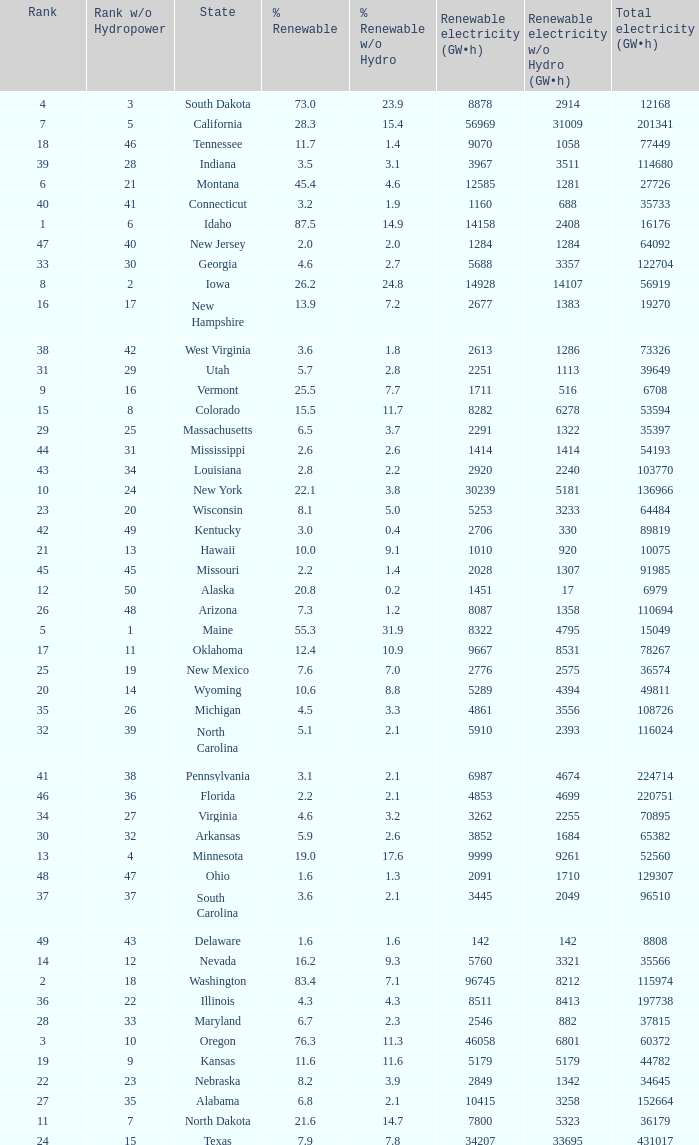What is the amount of renewable electricity without hydrogen power when the percentage of renewable energy is 83.4? 8212.0. 